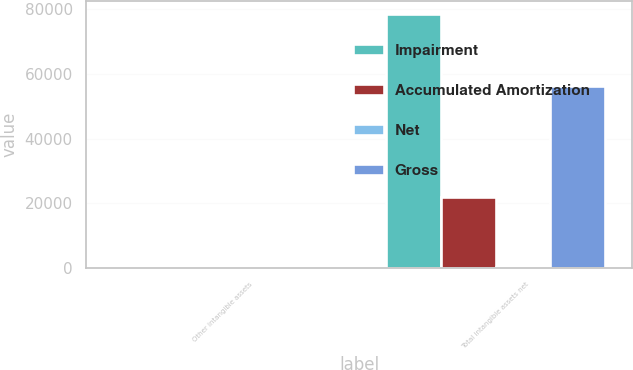Convert chart to OTSL. <chart><loc_0><loc_0><loc_500><loc_500><stacked_bar_chart><ecel><fcel>Other intangible assets<fcel>Total intangible assets net<nl><fcel>Impairment<fcel>500<fcel>78488<nl><fcel>Accumulated Amortization<fcel>172<fcel>21973<nl><fcel>Net<fcel>291<fcel>291<nl><fcel>Gross<fcel>37<fcel>56224<nl></chart> 